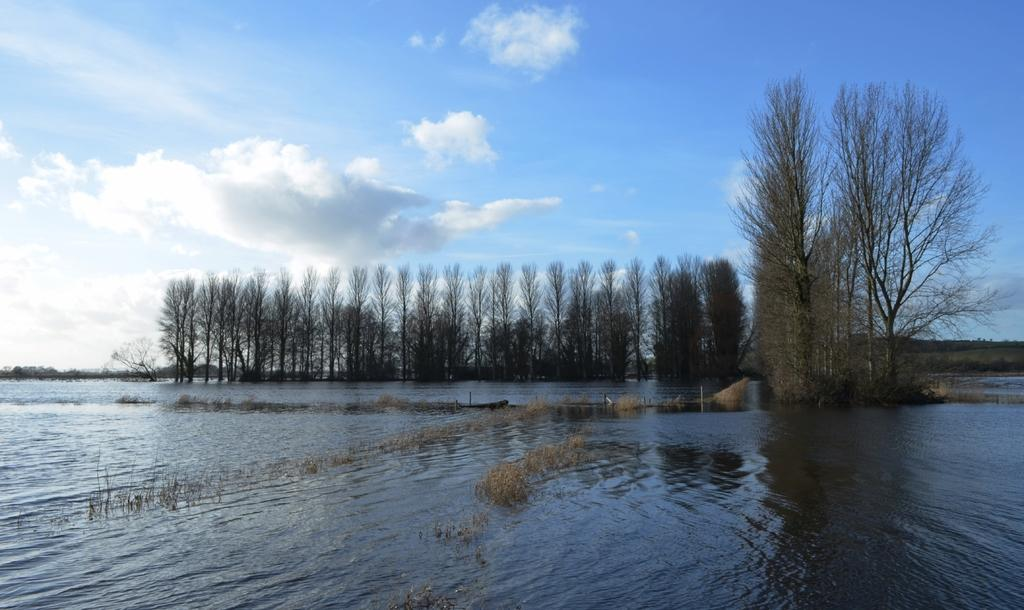What is at the bottom of the image? There is water at the bottom of the image. What can be seen in the background of the image? There are trees in the background of the image. What is visible in the sky in the image? The sky is visible in the image, and clouds are present. What type of marble is being used to play basketball in the image? There is no marble or basketball present in the image. 